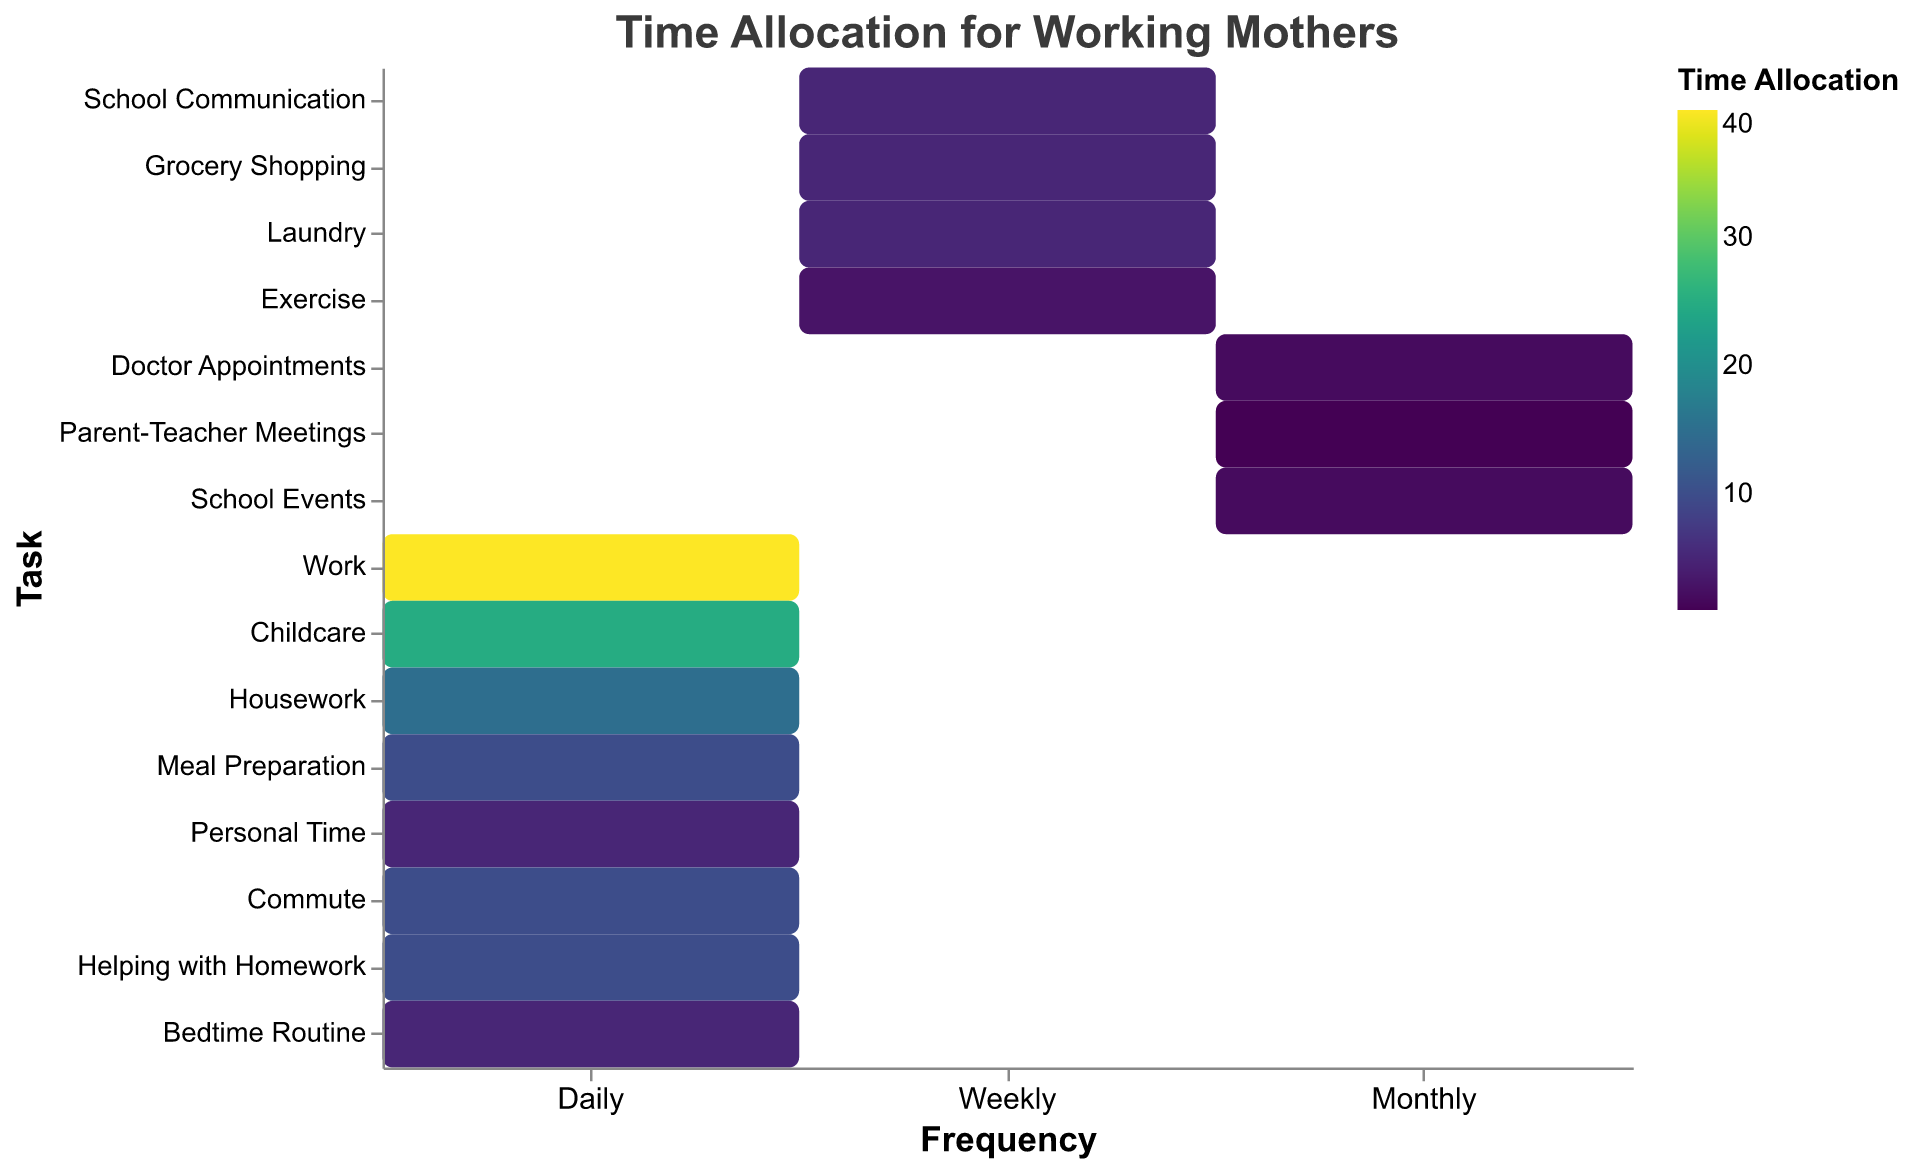What is the total amount of time allocated to daily tasks? To find the total time allocated to daily tasks, sum the time allocations for all tasks marked with 'Daily' frequency: Work (40), Childcare (25), Housework (15), Meal Preparation (10), Personal Time (5), Commute (10), Helping with Homework (10), Bedtime Routine (5). Total is 40 + 25 + 15 + 10 + 5 + 10 + 10 + 5 = 120 hours.
Answer: 120 hours What tasks have the least time allocated on a weekly basis? To identify the tasks with the least time allocated on a weekly basis, look at the frequency marked as 'Weekly'. The tasks are School Communication (5), Grocery Shopping (5), Laundry (5), and Exercise (3). Among these, Exercise has the least time allocation.
Answer: Exercise Which task takes the most amount of time overall regardless of frequency? By comparing the 'Time Allocation' of all tasks, Work has the highest time allocation at 40 hours.
Answer: Work How much time is allocated to tasks that involve school communication, including daily, weekly, and monthly frequencies? Sum the time allocations for tasks related to school communication: School Communication (5 weekly, approximately 0.71 hours daily), Helping with Homework (10 daily), Parent-Teacher Meetings (1 monthly, approximately 0.03 hours daily), and School Events (2 monthly, approximately 0.07 hours daily). Total daily time is 0.71 + 10 + 0.03 + 0.07 ≈ 10.81 hours.
Answer: 10.81 hours daily Is the time allocation for Meal Preparation higher than Commute? Compare the 'Time Allocation' for Meal Preparation (10 hours) with that for Commute (10 hours). Both tasks have the same time allocation.
Answer: No, they are equal How does the time allocated to Housework compare to Personal Time? Housework is allocated 15 hours, whereas Personal Time is allocated 5 hours. Housework has 15 - 5 = 10 more hours allocated compared to Personal Time.
Answer: Housework has 10 more hours What is the most time-consuming task with a monthly frequency? Among the tasks with 'Monthly' frequency, the allocations are Doctor Appointments (2), Parent-Teacher Meetings (1), and School Events (2). Doctor Appointments and School Events are the most time-consuming, each with 2 hours.
Answer: Doctor Appointments and School Events How much total time is spent on weekly tasks? Sum the time allocations for tasks marked with 'Weekly' frequency: School Communication (5), Grocery Shopping (5), Laundry (5), and Exercise (3). Total is 5 + 5 + 5 + 3 = 18 hours.
Answer: 18 hours Which task takes more time: Childcare or Helping with Homework? Compare the 'Time Allocation' for Childcare (25 hours) with Helping with Homework (10 hours). Childcare takes more time.
Answer: Childcare 